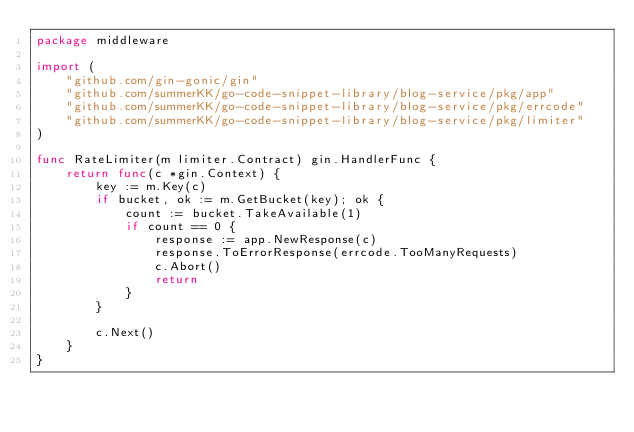Convert code to text. <code><loc_0><loc_0><loc_500><loc_500><_Go_>package middleware

import (
	"github.com/gin-gonic/gin"
	"github.com/summerKK/go-code-snippet-library/blog-service/pkg/app"
	"github.com/summerKK/go-code-snippet-library/blog-service/pkg/errcode"
	"github.com/summerKK/go-code-snippet-library/blog-service/pkg/limiter"
)

func RateLimiter(m limiter.Contract) gin.HandlerFunc {
	return func(c *gin.Context) {
		key := m.Key(c)
		if bucket, ok := m.GetBucket(key); ok {
			count := bucket.TakeAvailable(1)
			if count == 0 {
				response := app.NewResponse(c)
				response.ToErrorResponse(errcode.TooManyRequests)
				c.Abort()
				return
			}
		}

		c.Next()
	}
}
</code> 